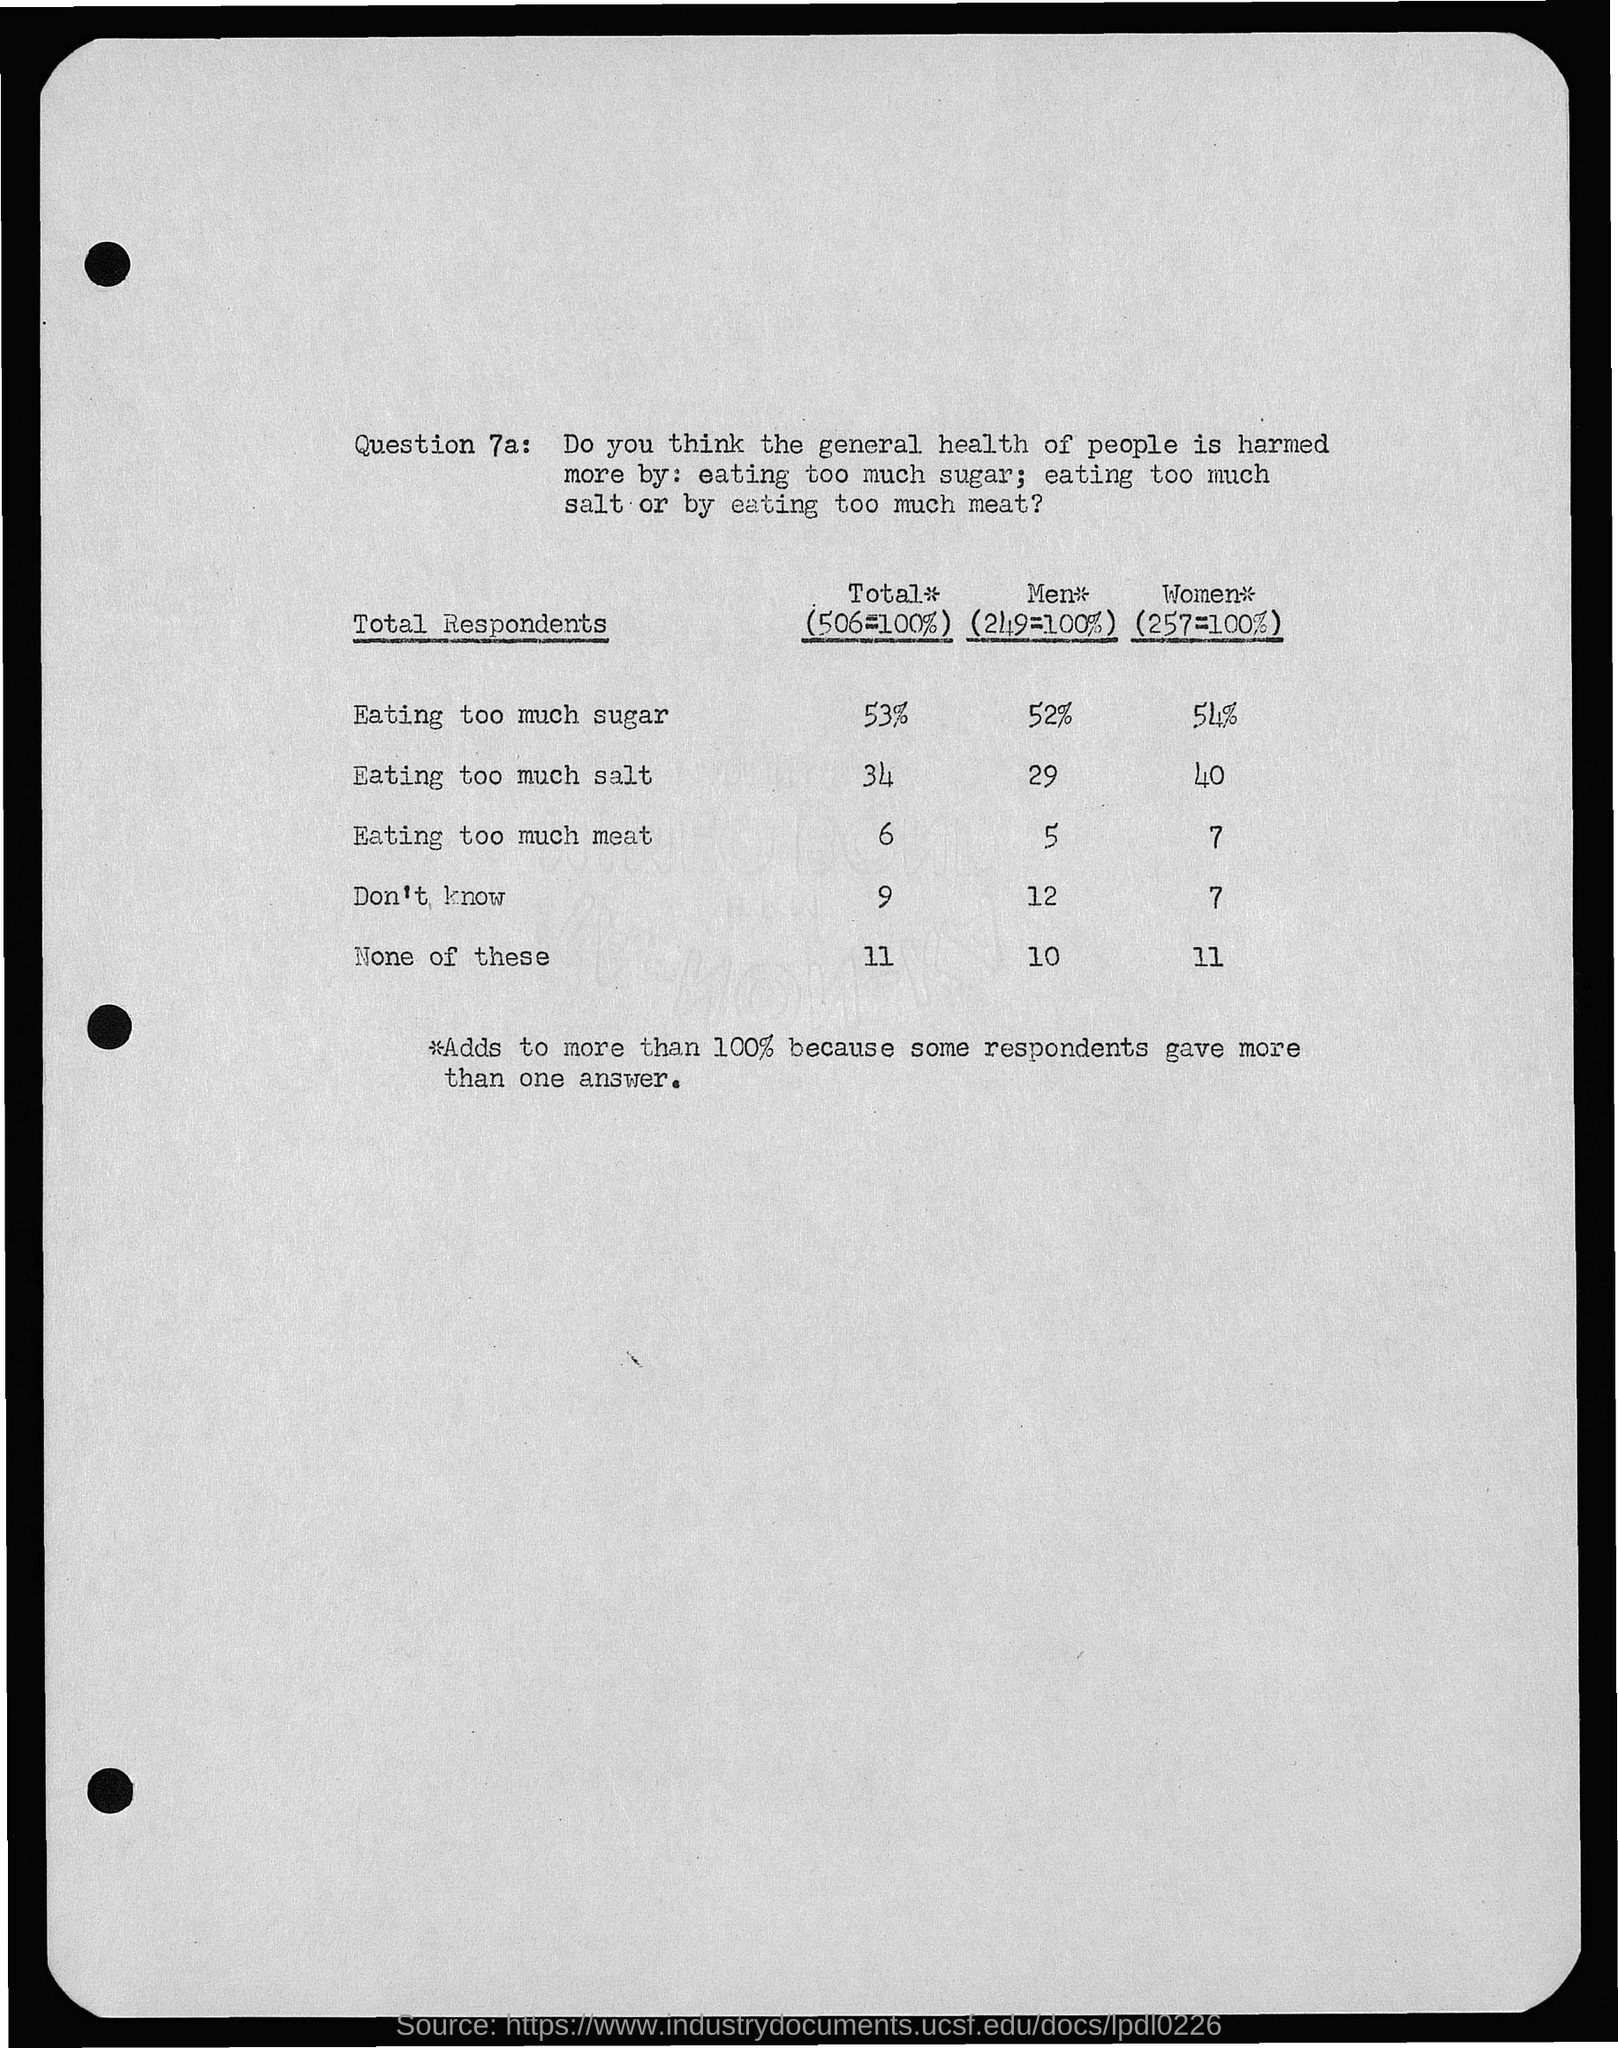List a handful of essential elements in this visual. The excessive consumption of salt by men is associated with a high prevalence of various health problems, including hypertension, heart disease, and kidney disease. A recent study found that consuming more than 29% of daily calories from salt is associated with an increased risk of developing cardiovascular disease in men. It is crucial to regulate the consumption of salt to maintain a healthy diet and prevent the development of chronic diseases. What is the question number 7a?" is a question asking for information about a specific question. In a recent survey, it was found that 53% of people reported eating too much sugar. According to a recent study, consuming excessive amounts of sugar can increase the risk of health problems in men by 52%. A recent study found that 54% of women consume too much sugar in their diet. 